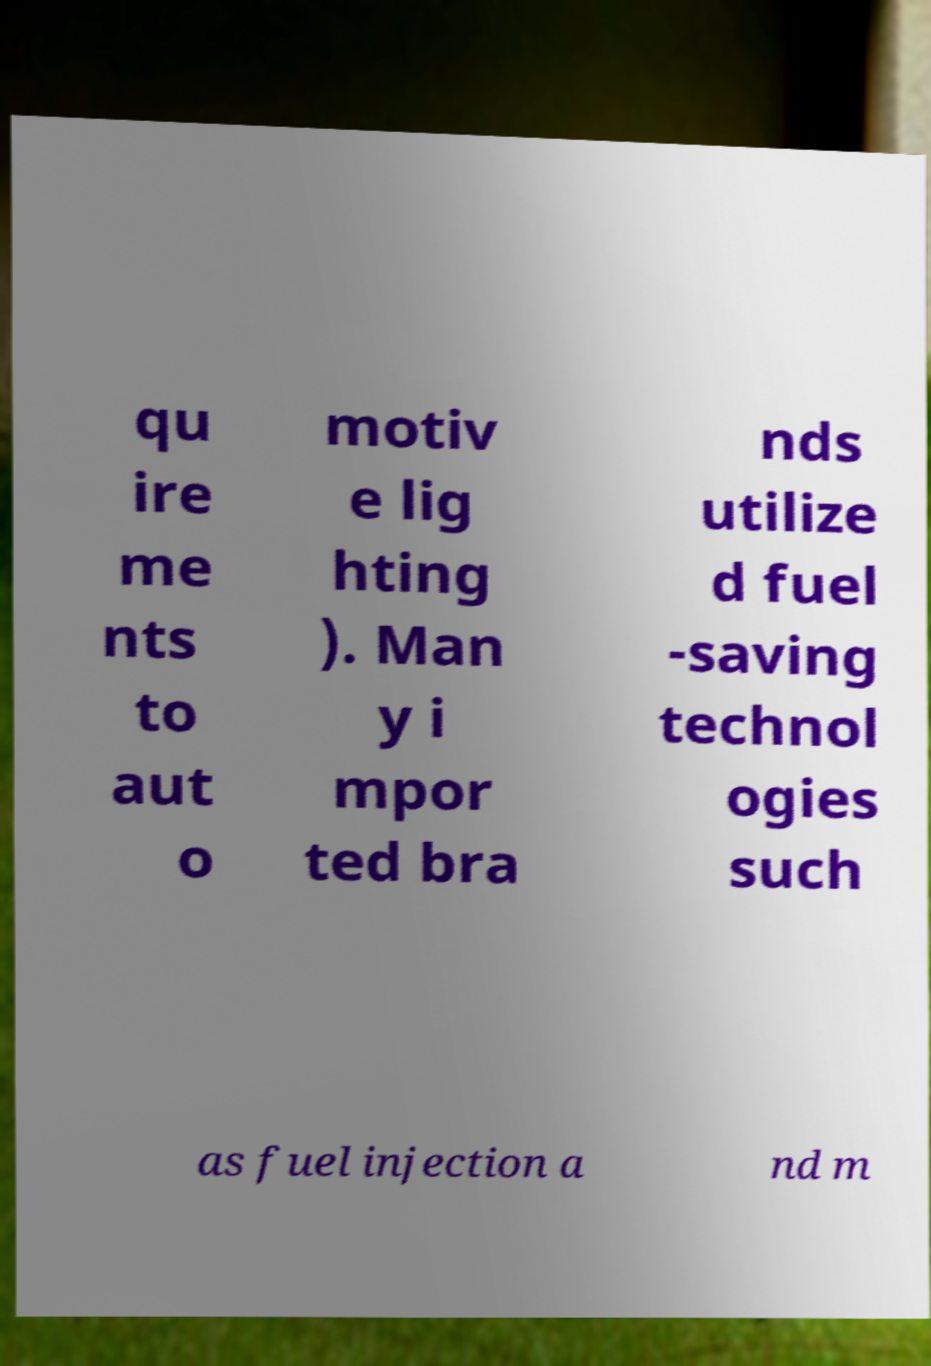For documentation purposes, I need the text within this image transcribed. Could you provide that? qu ire me nts to aut o motiv e lig hting ). Man y i mpor ted bra nds utilize d fuel -saving technol ogies such as fuel injection a nd m 